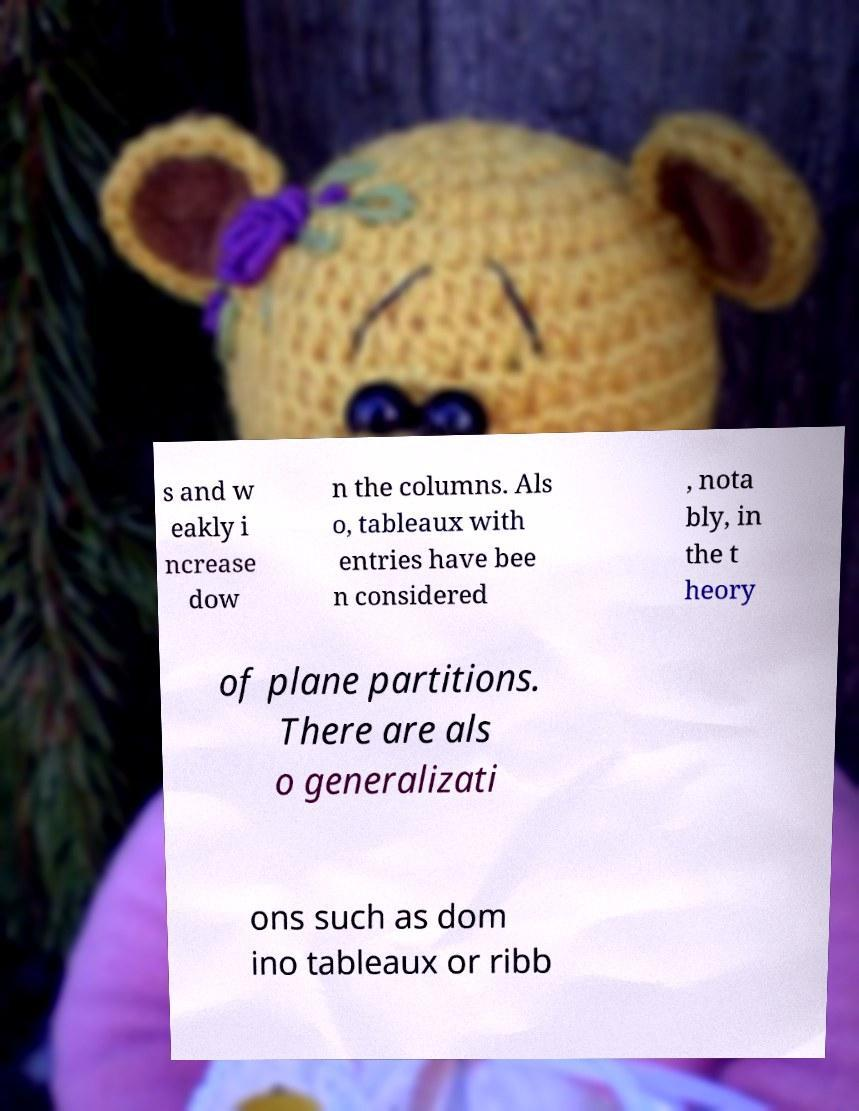Please identify and transcribe the text found in this image. s and w eakly i ncrease dow n the columns. Als o, tableaux with entries have bee n considered , nota bly, in the t heory of plane partitions. There are als o generalizati ons such as dom ino tableaux or ribb 